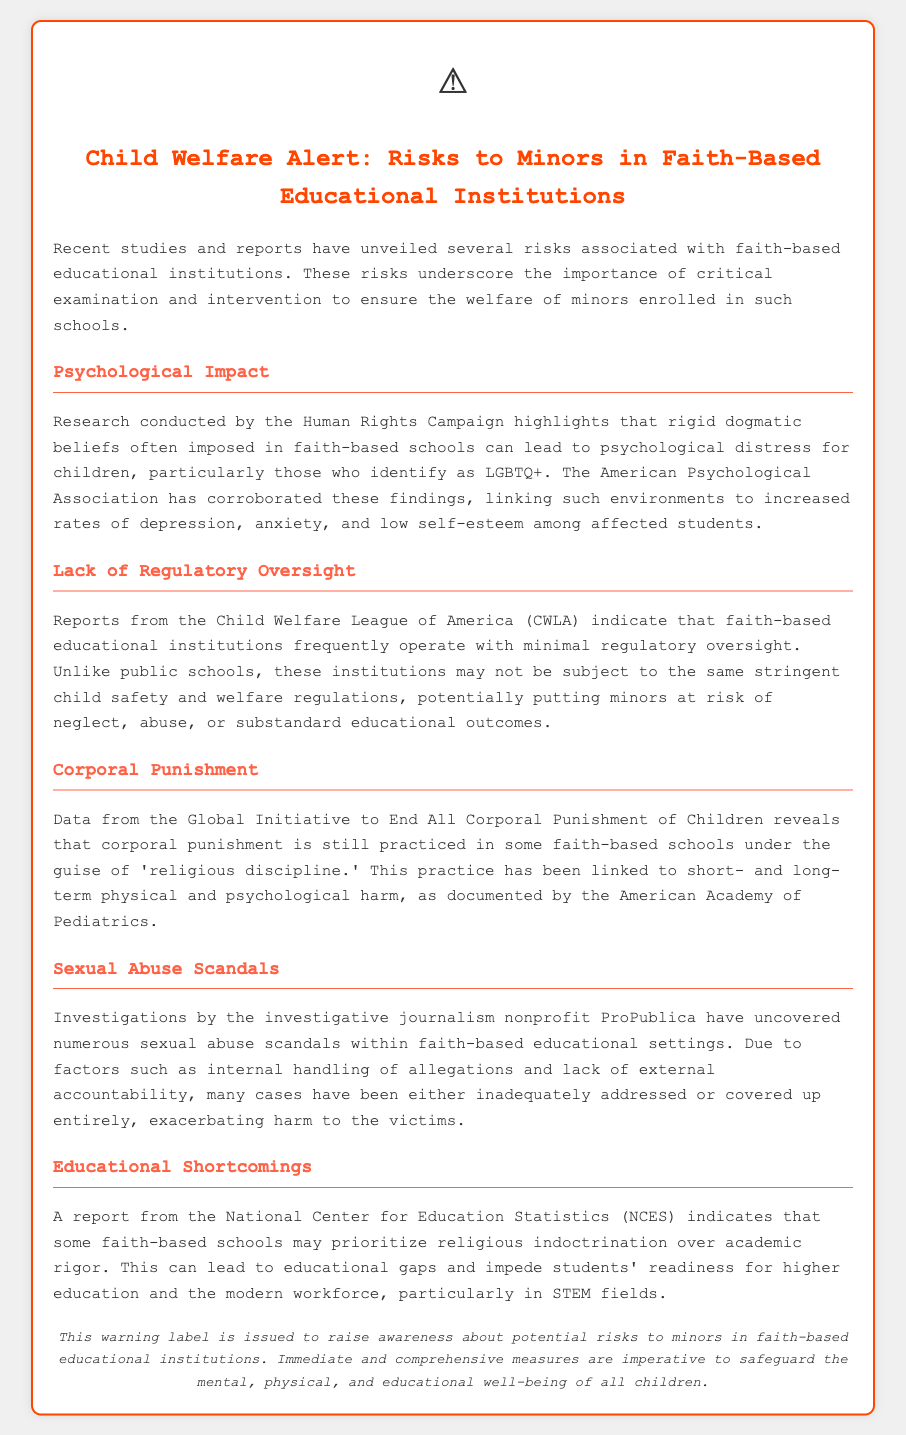What are the psychological impacts linked to faith-based schools? The document mentions that rigid dogmatic beliefs can lead to psychological distress, including increased rates of depression, anxiety, and low self-esteem among affected students.
Answer: Depression, anxiety, low self-esteem What organization corroborates the findings about psychological impacts? The American Psychological Association is mentioned as an organization that corroborates the findings regarding the psychological impact on students.
Answer: American Psychological Association Which entity reports minimal regulatory oversight in faith-based educational institutions? The Child Welfare League of America (CWLA) is cited in the document as reporting that faith-based educational institutions operate with minimal regulatory oversight.
Answer: Child Welfare League of America What harmful practice is linked to 'religious discipline' in some faith-based schools? The document discusses corporal punishment as a harmful practice still practiced in some faith-based schools under 'religious discipline.'
Answer: Corporal punishment What investigative organization uncovered sexual abuse scandals in faith-based schools? The investigative journalism nonprofit ProPublica is noted for uncovering numerous sexual abuse scandals within faith-based educational settings.
Answer: ProPublica What is a potential educational shortcoming identified in faith-based institutions? The report indicates that some faith-based schools may prioritize religious indoctrination over academic rigor, leading to educational gaps.
Answer: Educational gaps What is the primary purpose of this warning label? The document states that the warning label is issued to raise awareness about potential risks to minors in faith-based educational institutions.
Answer: Raise awareness How should immediate measures address the risks highlighted in the document? The document emphasizes that immediate and comprehensive measures are imperative to safeguard the mental, physical, and educational well-being of all children.
Answer: Safeguard children's well-being 